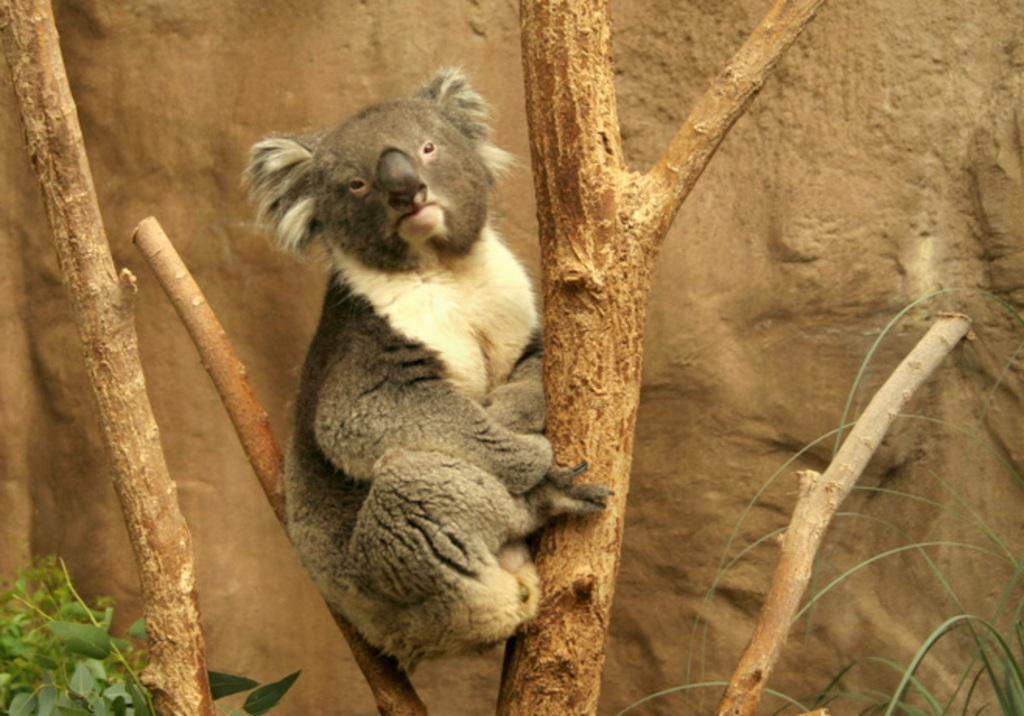Please provide a concise description of this image. In this image I can see a koala on a tree trunk. At the bottom few leaves are visible. In the background there is a rock. 